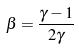<formula> <loc_0><loc_0><loc_500><loc_500>\beta = \frac { \gamma - 1 } { 2 \gamma }</formula> 